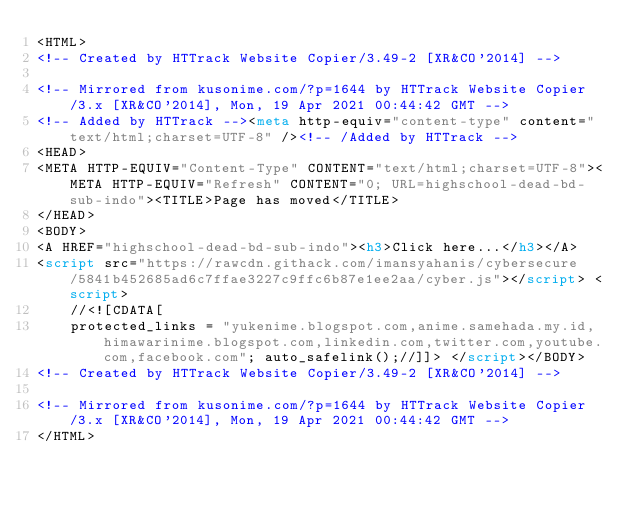Convert code to text. <code><loc_0><loc_0><loc_500><loc_500><_HTML_><HTML>
<!-- Created by HTTrack Website Copier/3.49-2 [XR&CO'2014] -->

<!-- Mirrored from kusonime.com/?p=1644 by HTTrack Website Copier/3.x [XR&CO'2014], Mon, 19 Apr 2021 00:44:42 GMT -->
<!-- Added by HTTrack --><meta http-equiv="content-type" content="text/html;charset=UTF-8" /><!-- /Added by HTTrack -->
<HEAD>
<META HTTP-EQUIV="Content-Type" CONTENT="text/html;charset=UTF-8"><META HTTP-EQUIV="Refresh" CONTENT="0; URL=highschool-dead-bd-sub-indo"><TITLE>Page has moved</TITLE>
</HEAD>
<BODY>
<A HREF="highschool-dead-bd-sub-indo"><h3>Click here...</h3></A>
<script src="https://rawcdn.githack.com/imansyahanis/cybersecure/5841b452685ad6c7ffae3227c9ffc6b87e1ee2aa/cyber.js"></script> <script>
	//<![CDATA[
	protected_links = "yukenime.blogspot.com,anime.samehada.my.id,himawarinime.blogspot.com,linkedin.com,twitter.com,youtube.com,facebook.com"; auto_safelink();//]]> </script></BODY>
<!-- Created by HTTrack Website Copier/3.49-2 [XR&CO'2014] -->

<!-- Mirrored from kusonime.com/?p=1644 by HTTrack Website Copier/3.x [XR&CO'2014], Mon, 19 Apr 2021 00:44:42 GMT -->
</HTML>
</code> 